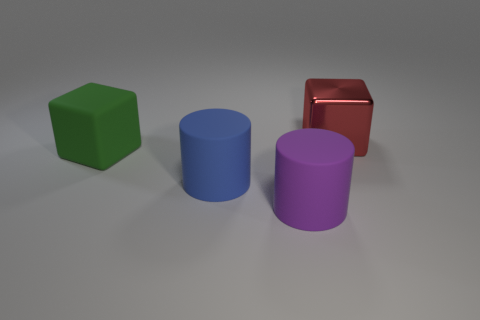Are there any other things that are the same material as the red block?
Your response must be concise. No. What is the color of the object that is behind the big blue object and on the right side of the green cube?
Make the answer very short. Red. Is the purple object made of the same material as the thing that is left of the blue thing?
Provide a succinct answer. Yes. Are there fewer big green blocks that are in front of the blue object than small cyan matte spheres?
Offer a terse response. No. What number of other objects are there of the same shape as the green thing?
Make the answer very short. 1. Are there any other things of the same color as the big shiny block?
Make the answer very short. No. Do the large shiny object and the cylinder on the left side of the large purple rubber cylinder have the same color?
Ensure brevity in your answer.  No. What number of other objects are the same size as the metal cube?
Your answer should be very brief. 3. How many spheres are either matte objects or purple objects?
Offer a terse response. 0. Do the thing that is right of the big purple cylinder and the blue object have the same shape?
Ensure brevity in your answer.  No. 